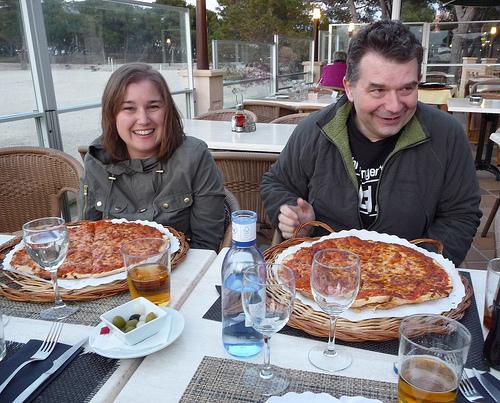Question: where was the picture taken?
Choices:
A. At home.
B. At school.
C. At church.
D. At a restaurant.
Answer with the letter. Answer: D Question: what are the people doing?
Choices:
A. Talking.
B. Eating.
C. Walking.
D. Posing for the picture.
Answer with the letter. Answer: D Question: what are the people eating?
Choices:
A. Sandwiches.
B. Pizza.
C. Crackers.
D. Chips.
Answer with the letter. Answer: B Question: who is in the picture?
Choices:
A. A kid.
B. A man and women.
C. Children.
D. A man.
Answer with the letter. Answer: B Question: what color jacket is the women wearing?
Choices:
A. White.
B. Gray.
C. Blue.
D. Yellow.
Answer with the letter. Answer: B Question: how many people are in the picture?
Choices:
A. 3.
B. 4.
C. 2.
D. 5.
Answer with the letter. Answer: C 